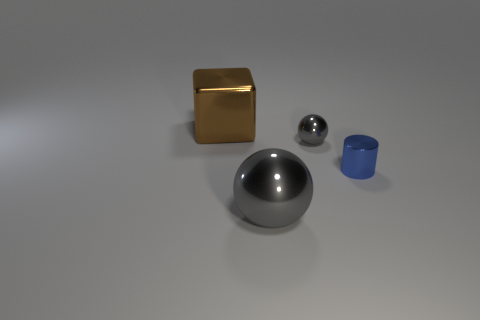Add 2 big gray matte cubes. How many objects exist? 6 Subtract all blocks. How many objects are left? 3 Subtract 0 yellow cylinders. How many objects are left? 4 Subtract all shiny balls. Subtract all large things. How many objects are left? 0 Add 2 shiny cylinders. How many shiny cylinders are left? 3 Add 1 brown metallic blocks. How many brown metallic blocks exist? 2 